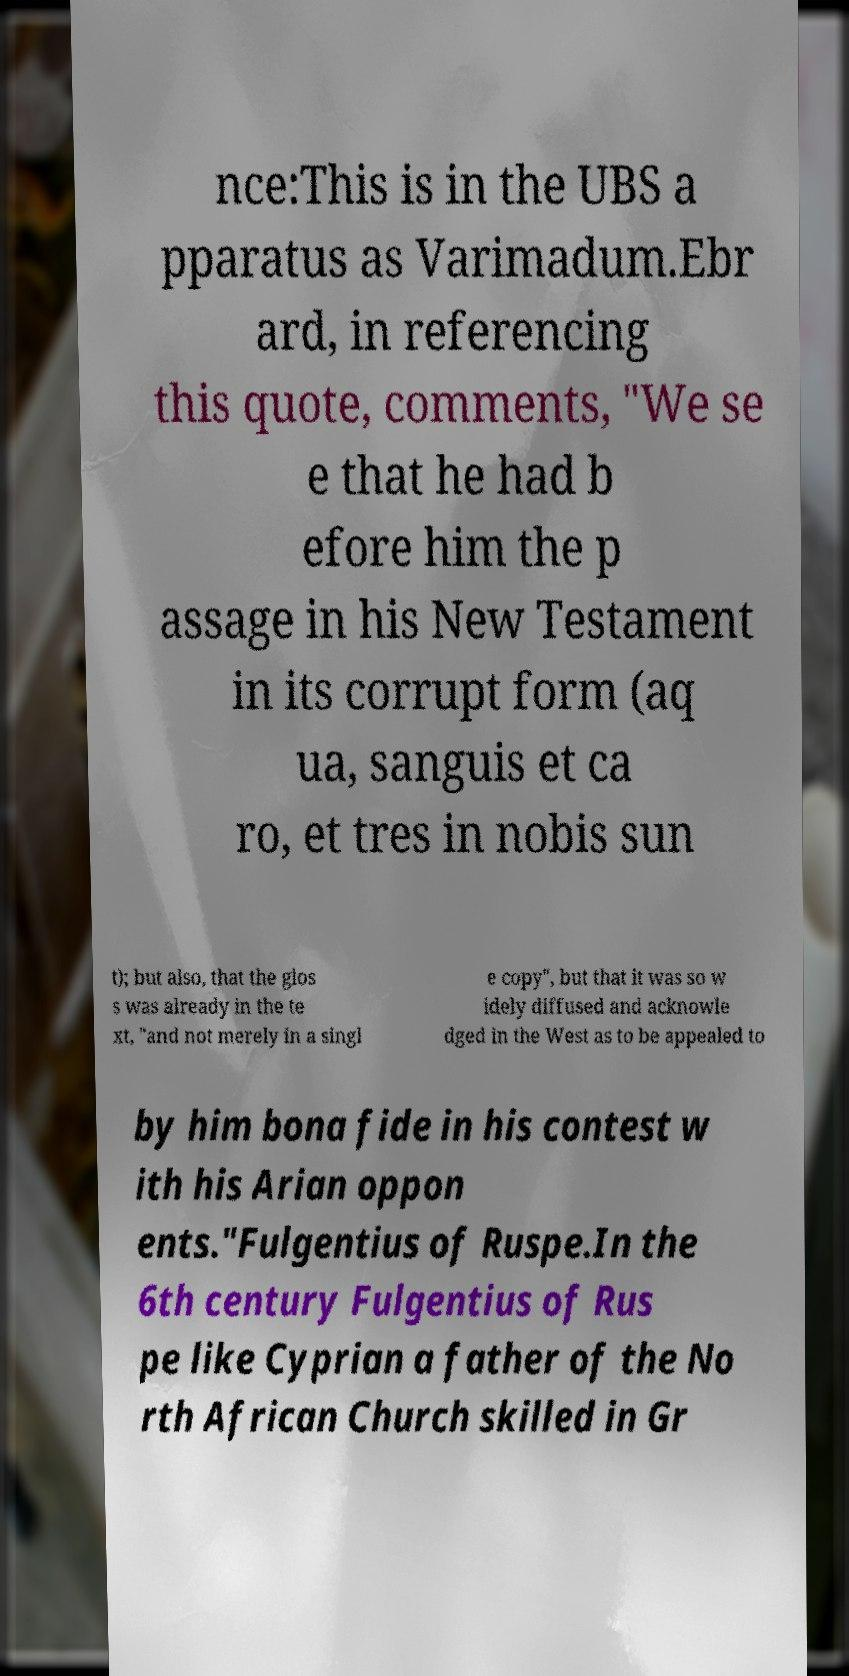For documentation purposes, I need the text within this image transcribed. Could you provide that? nce:This is in the UBS a pparatus as Varimadum.Ebr ard, in referencing this quote, comments, "We se e that he had b efore him the p assage in his New Testament in its corrupt form (aq ua, sanguis et ca ro, et tres in nobis sun t); but also, that the glos s was already in the te xt, "and not merely in a singl e copy", but that it was so w idely diffused and acknowle dged in the West as to be appealed to by him bona fide in his contest w ith his Arian oppon ents."Fulgentius of Ruspe.In the 6th century Fulgentius of Rus pe like Cyprian a father of the No rth African Church skilled in Gr 